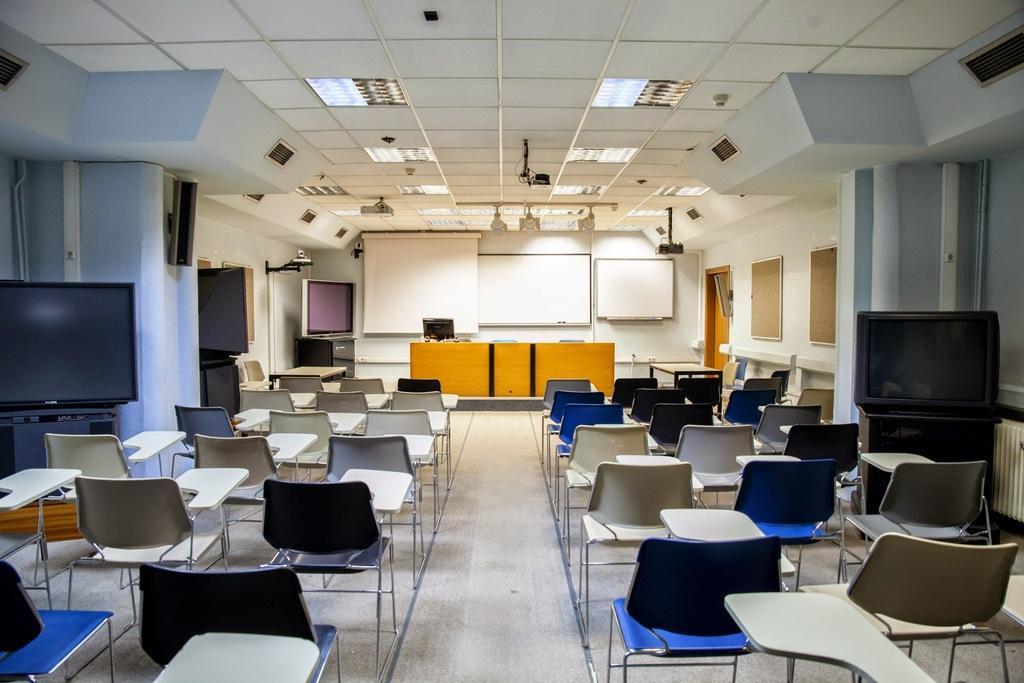Describe this image in one or two sentences. Inside this room we can see monitors, chairs, tables, camera, boards, screen, projector, lights and door. Lights are attached to the ceiling. Camera and speakers are on the wall. 